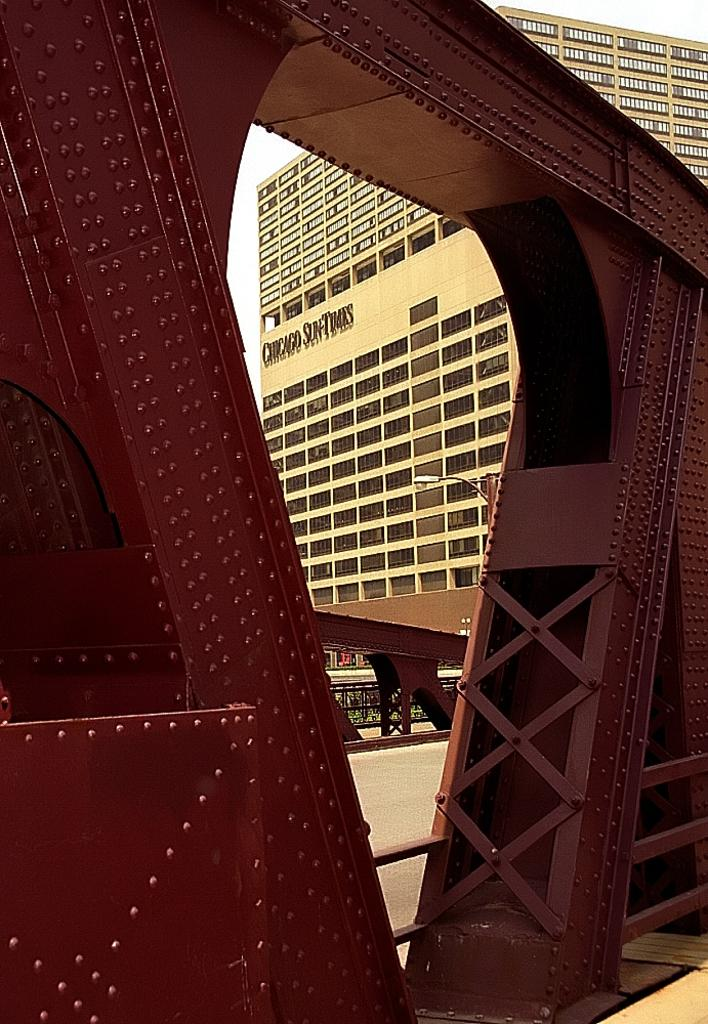What type of structure is visible in the image? There is an iron frame in the image. What can be seen in the background of the image? There is a building in the backdrop of the image. What feature of the building is mentioned in the facts? The building has windows. How would you describe the weather based on the image? The sky is clear in the image, suggesting good weather. How much does the iron mine weigh in the image? There is no iron mine present in the image, so it is not possible to determine its weight. 